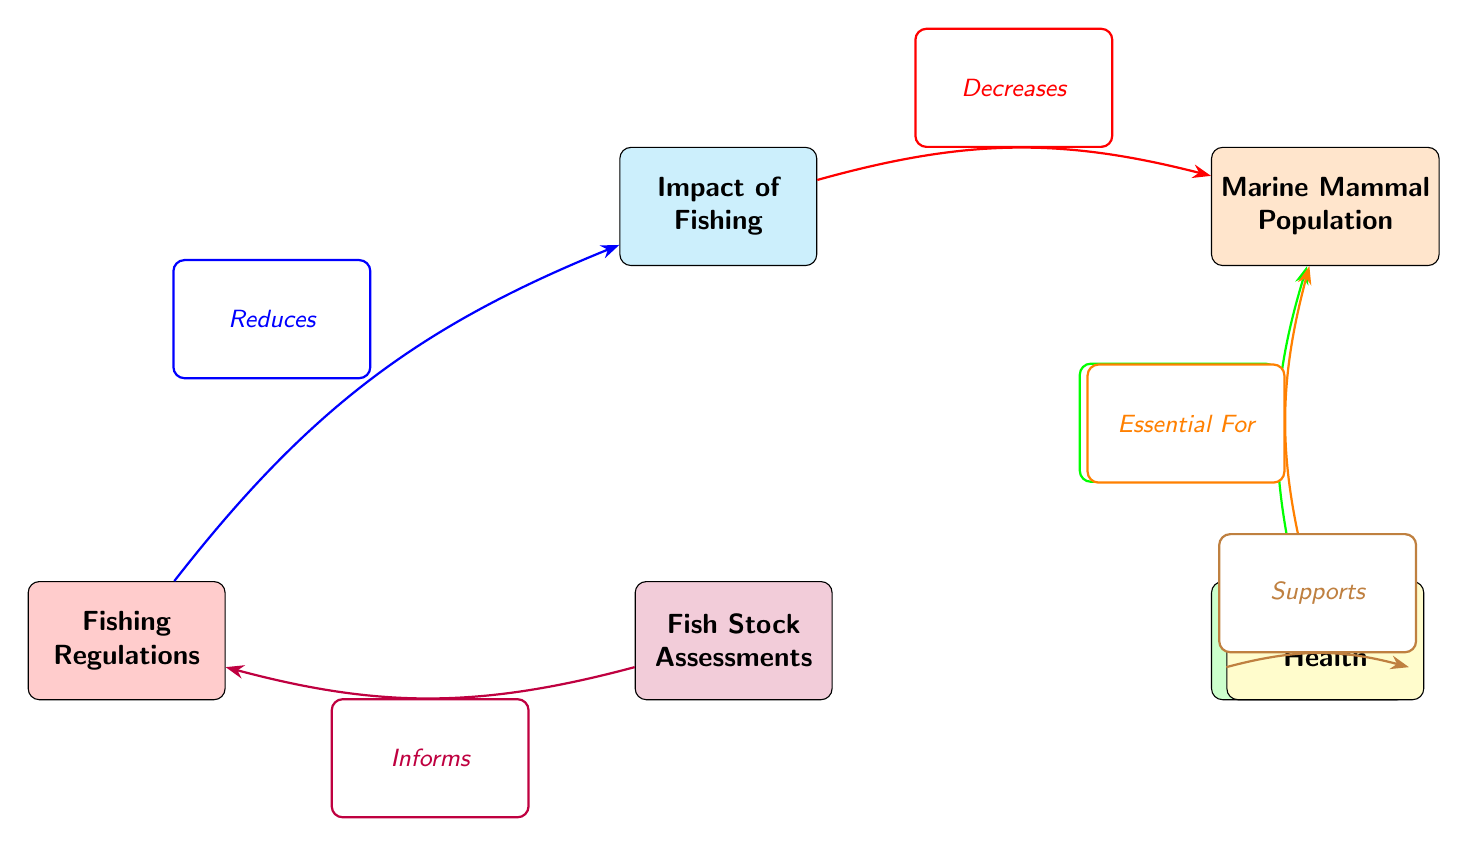What is the relationship between fishing impact and marine mammal population? The diagram indicates that fishing impact decreases marine mammal population, as shown by the red edge labeled "Decreases."
Answer: Decreases How many nodes are present in the diagram? There are six nodes in total: Impact of Fishing, Marine Mammal Population, Conservation Programs, Fishing Regulations, Ecosystem Health, and Fish Stock Assessments.
Answer: 6 What role do conservation programs play in relation to marine mammal population? Conservation programs are shown to increase marine mammal population, represented by the green edge labeled "Increases."
Answer: Increases Which node informs fishing regulations? The diagram indicates that fish stock assessments inform fishing regulations, as labeled by the purple edge "Informs."
Answer: Fish Stock Assessments How does ecosystem health relate to conservation programs? Ecosystem health supports conservation programs, as indicated by the brown edge labeled "Supports." This shows a positive interaction between the two nodes.
Answer: Supports What effect do fishing regulations have on fishing impact? Fishing regulations are depicted to reduce fishing impact, as conveyed by the blue edge labeled "Reduces."
Answer: Reduces What is essential for marine mammal population? Ecosystem health is labeled as essential for marine mammal population, demonstrated by the orange edge labeled "Essential For."
Answer: Ecosystem Health What flows from ecosystem health to marine mammal population? The diagram indicates that ecosystem health is essential for marine mammal population, shown by the orange edge.
Answer: Essential For 